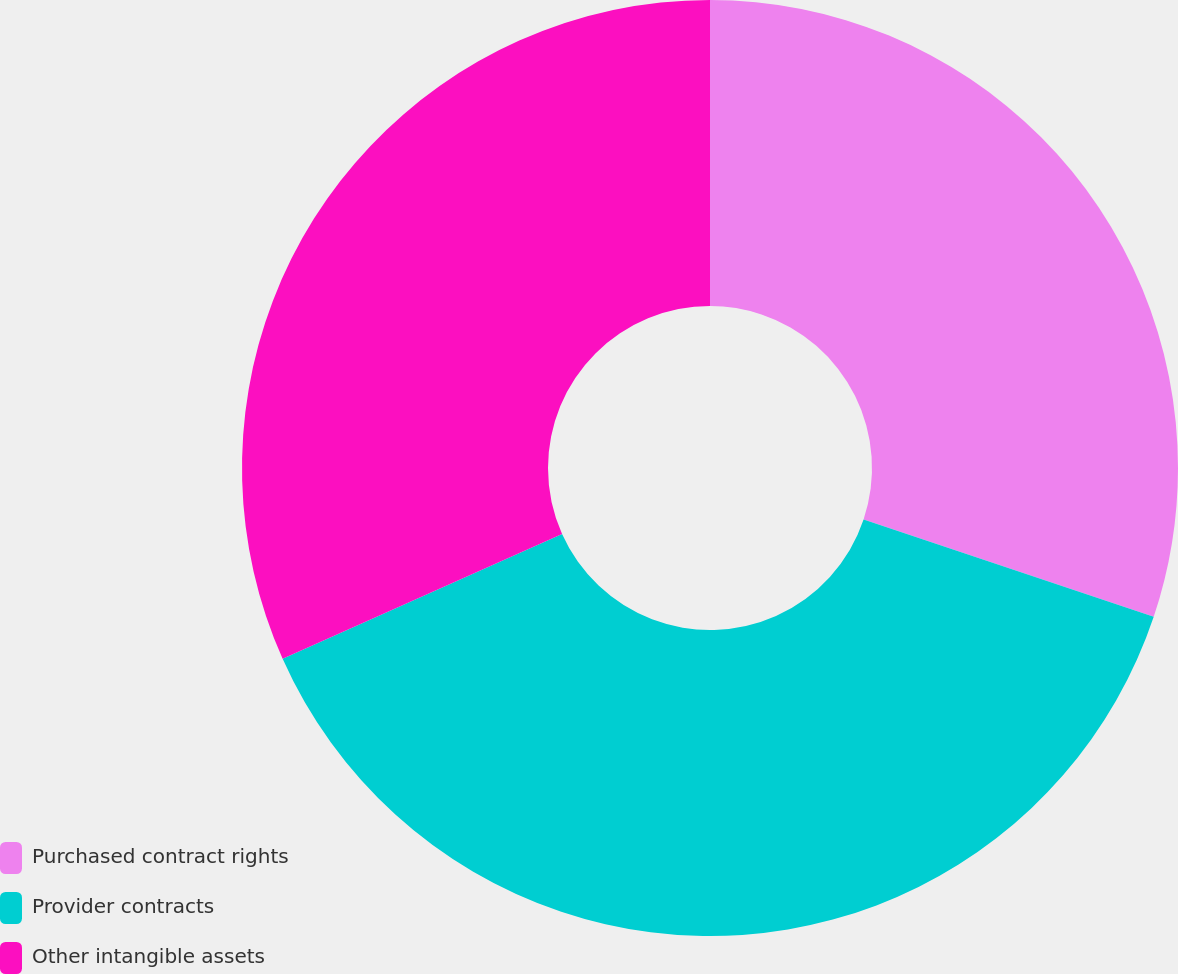Convert chart to OTSL. <chart><loc_0><loc_0><loc_500><loc_500><pie_chart><fcel>Purchased contract rights<fcel>Provider contracts<fcel>Other intangible assets<nl><fcel>30.15%<fcel>38.17%<fcel>31.68%<nl></chart> 